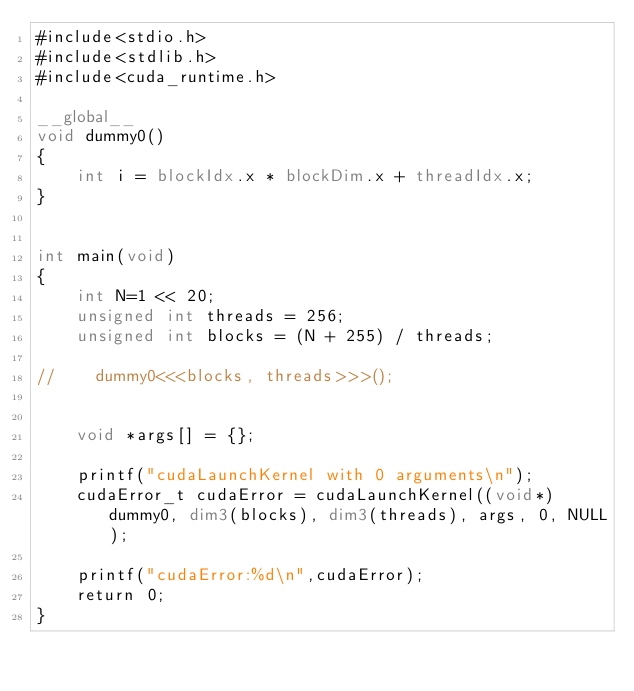Convert code to text. <code><loc_0><loc_0><loc_500><loc_500><_Cuda_>#include<stdio.h>
#include<stdlib.h>
#include<cuda_runtime.h>

__global__
void dummy0()
{
    int i = blockIdx.x * blockDim.x + threadIdx.x;
}


int main(void)
{
    int N=1 << 20;
    unsigned int threads = 256;
    unsigned int blocks = (N + 255) / threads;

//    dummy0<<<blocks, threads>>>();


    void *args[] = {};

    printf("cudaLaunchKernel with 0 arguments\n");
    cudaError_t cudaError = cudaLaunchKernel((void*)dummy0, dim3(blocks), dim3(threads), args, 0, NULL);

    printf("cudaError:%d\n",cudaError);
    return 0;
}
</code> 